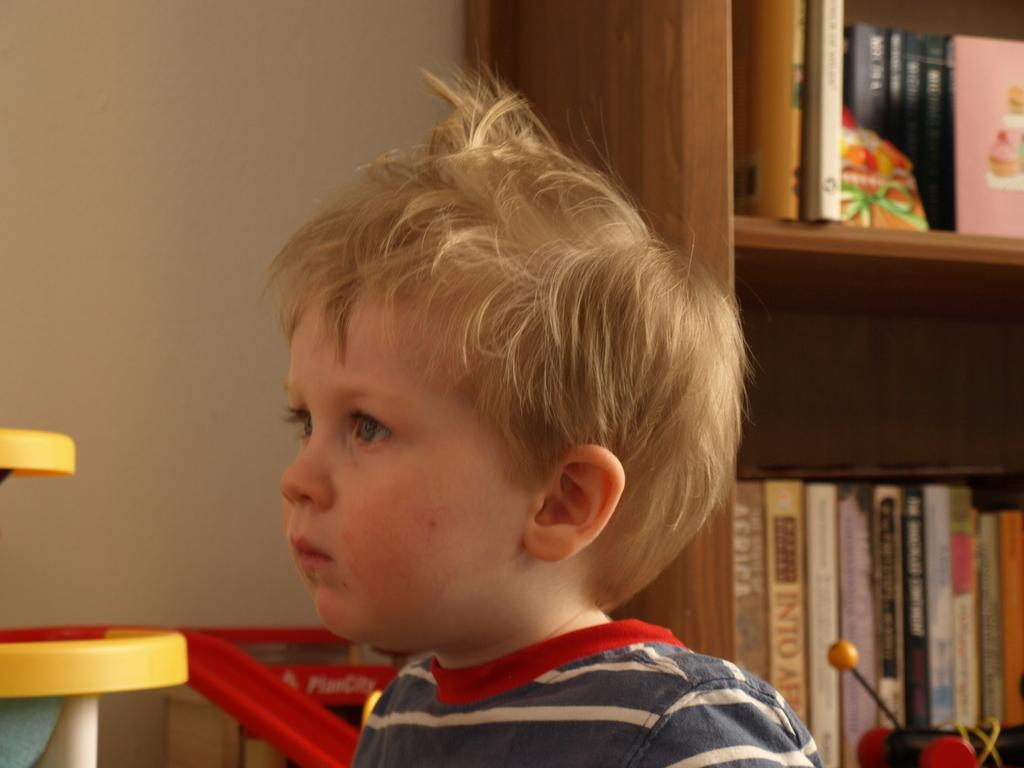What is the main subject in the front of the image? There is a kid in the front of the image. What can be seen on the right side of the image? There is a rack on the right side of the image. What is on the rack? There are books on the rack. What is on the left side of the image? There is a wall on the left side of the image. What type of sticks can be seen bursting out of the wall in the image? There are no sticks or any bursting objects present in the image. 